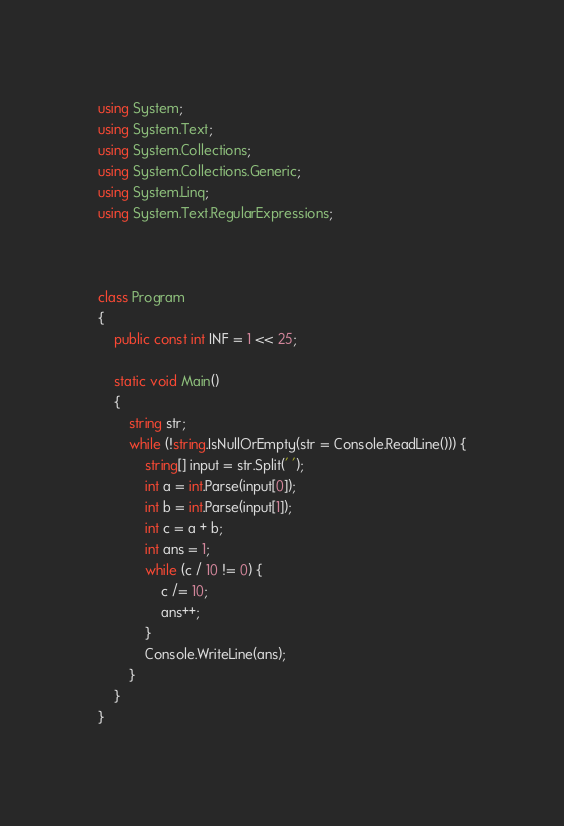<code> <loc_0><loc_0><loc_500><loc_500><_C#_>using System;
using System.Text;
using System.Collections;
using System.Collections.Generic;
using System.Linq;
using System.Text.RegularExpressions;



class Program
{
    public const int INF = 1 << 25;

    static void Main()
    {
		string str;
		while (!string.IsNullOrEmpty(str = Console.ReadLine())) {
			string[] input = str.Split(' ');
			int a = int.Parse(input[0]);
			int b = int.Parse(input[1]);
			int c = a + b;
			int ans = 1;
			while (c / 10 != 0) {
				c /= 10;
				ans++;
			}
			Console.WriteLine(ans);
		}
	}
}</code> 